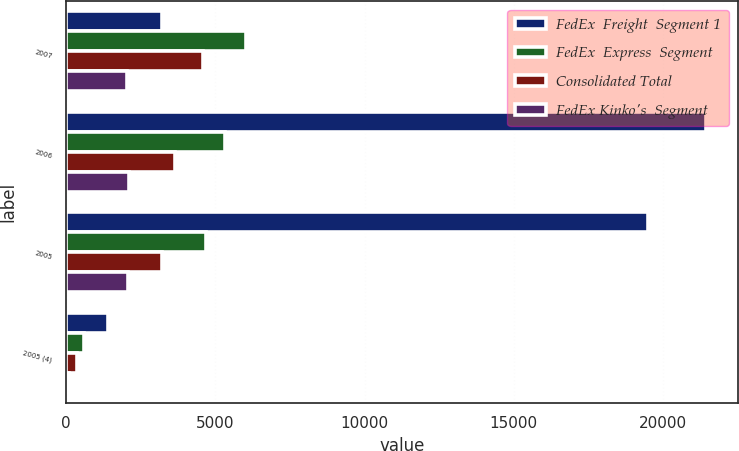Convert chart. <chart><loc_0><loc_0><loc_500><loc_500><stacked_bar_chart><ecel><fcel>2007<fcel>2006<fcel>2005<fcel>2005 (4)<nl><fcel>FedEx  Freight  Segment 1<fcel>3217<fcel>21446<fcel>19485<fcel>1414<nl><fcel>FedEx  Express  Segment<fcel>6043<fcel>5306<fcel>4680<fcel>604<nl><fcel>Consolidated Total<fcel>4586<fcel>3645<fcel>3217<fcel>354<nl><fcel>FedEx Kinko's  Segment<fcel>2040<fcel>2088<fcel>2066<fcel>100<nl></chart> 